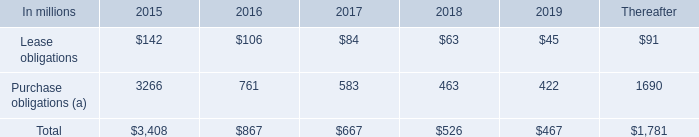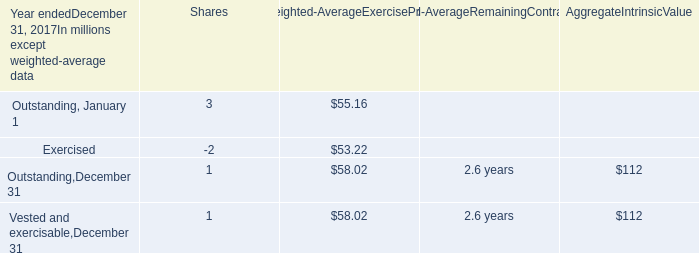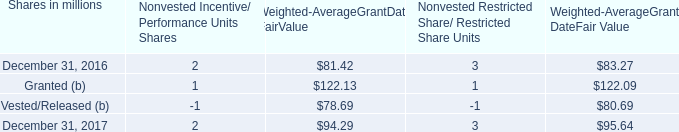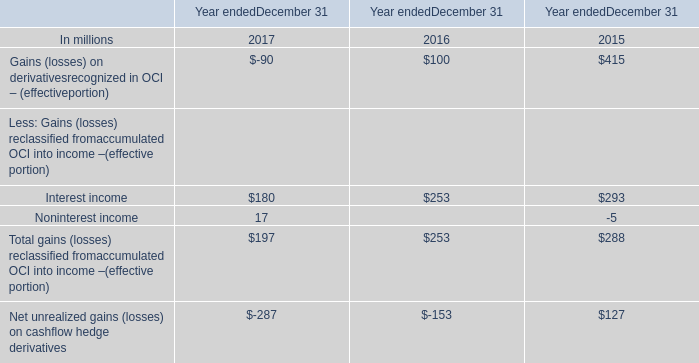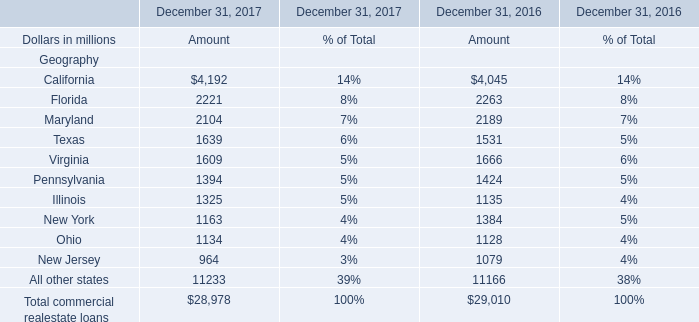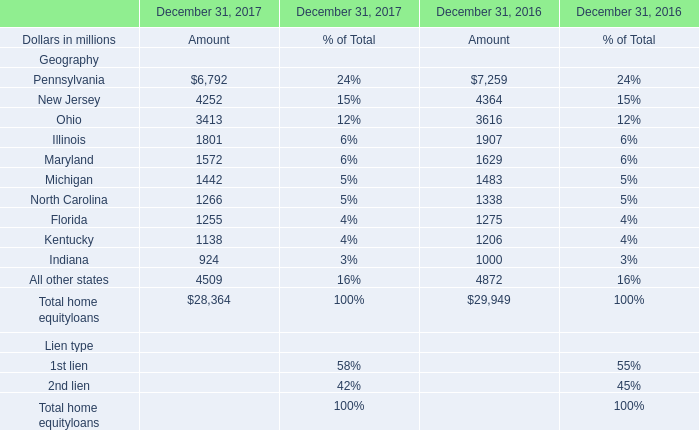Is the total amount of all elements in 2017 greater than that in 2016? 
Answer: No. 